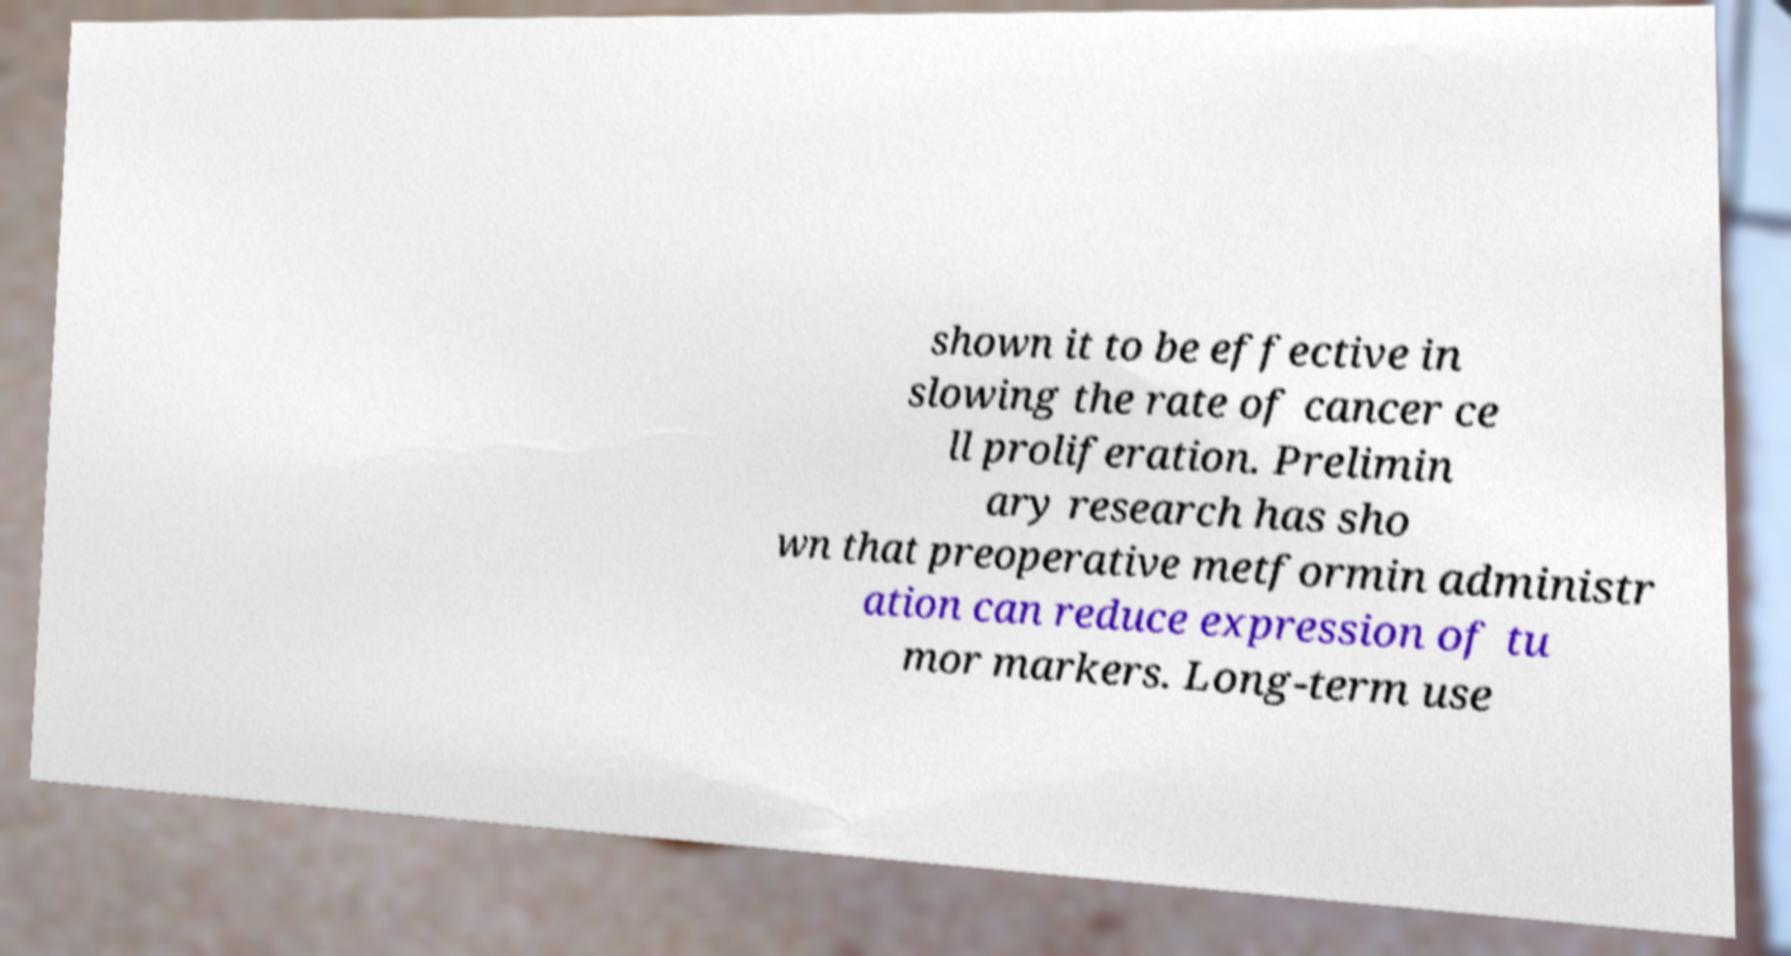Could you extract and type out the text from this image? shown it to be effective in slowing the rate of cancer ce ll proliferation. Prelimin ary research has sho wn that preoperative metformin administr ation can reduce expression of tu mor markers. Long-term use 